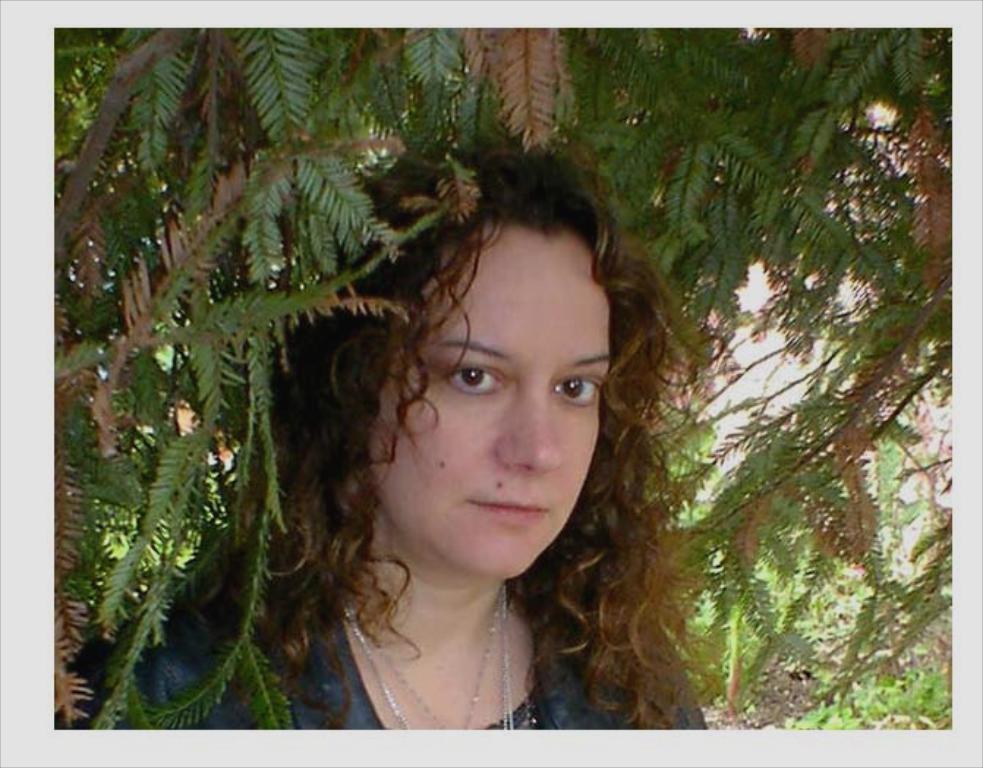Describe this image in one or two sentences. In this image there is a woman standing. Behind her there are leaves of a tree. 